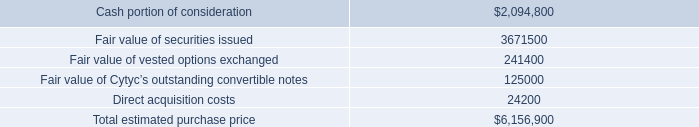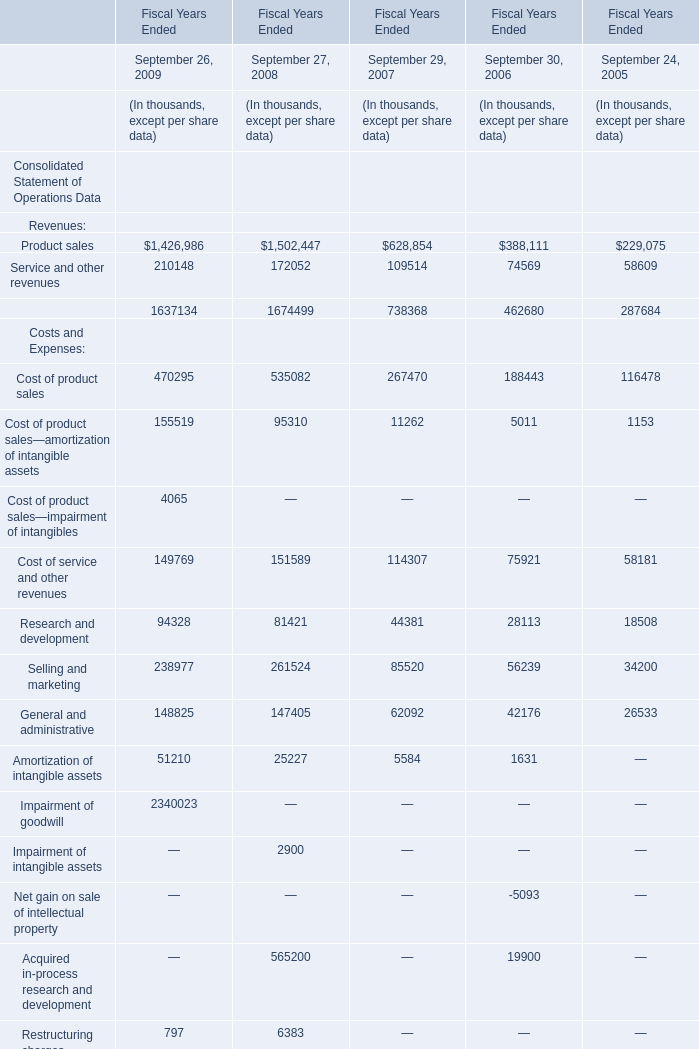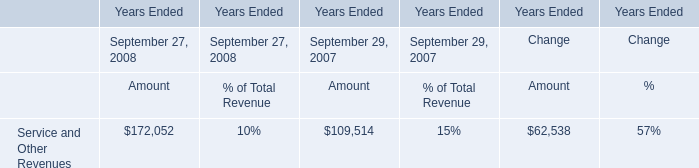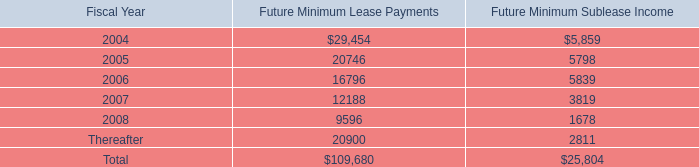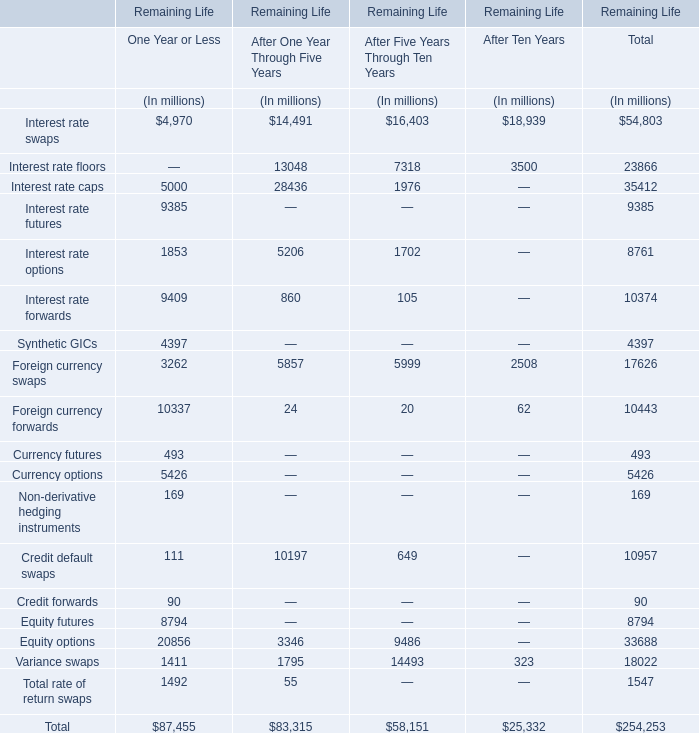what is the highest total amount of Foreign currency swaps? (in million) 
Answer: 5999. 